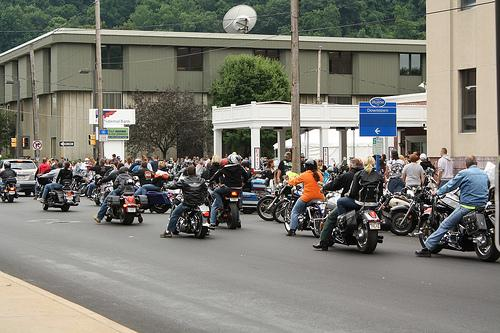Describe the ambiance of the image based on the objects present and their features. The image has a lively feel, as a group of people ride motorcycles on a street surrounded by trees, signs, and buildings on a daytime. Describe the location and the main objects in the image. The image takes place outdoors on a street with bikers riding motorcycles, a large healthy tree, a white building pillar, and a large building. Find objects above the street and describe them. Objects above the street are a satellite dish, a large green tree, a window on the building, and a sign pointing toward downtown. Identify the primary subjects in the image and provide some details about their surroundings. A large crowd of bikers, wearing various clothes, surrounded by a tall green tree, signs, and buildings such as a large beige-colored building near the street. What is the most noticeable thing in the image and what is happening around it? A group of people riding motorcycles is the most noticeable, with a variety of bikers wearing different clothing and a large building in the background. Write a brief description of the setting and the main focus of the image. An outdoor scene with a group of bikers riding motorcycles on a street surrounded by buildings, trees, and various signs. Identify the types of clothing the bikers are wearing in the photograph. The bikers in the image are wearing orange shirts, leather jackets, denim outfits, and a person wearing a gray hoodie and a pedestrian in a red hoodie. Mention the primary activity happening in the image and identify the main participants. A large crowd of bikers is riding motorcycles on the street, including people wearing orange shirts, leather jackets, and denim outfits. What dominates the image and mention a few adjacent objects? A large crowd of bikers dominates the image, which includes a man wearing a hooded sweatshirt, a large healthy tree, and a sign pointing toward downtown nearby. Mention an event in the image and provide some contextual objects around it. A man on a motorcycle is wearing a jean jacket, while nearby there is a crowd of bikers, a window on a building, and a large tree. 